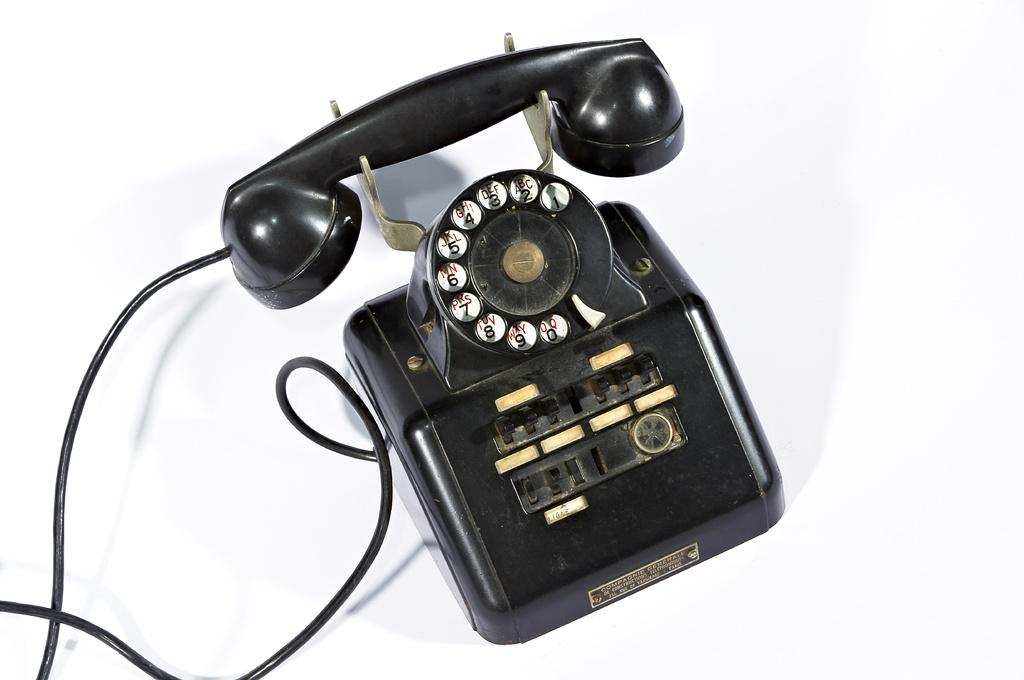<image>
Write a terse but informative summary of the picture. A black old-fashioned telephone with the name Ligne on it. 